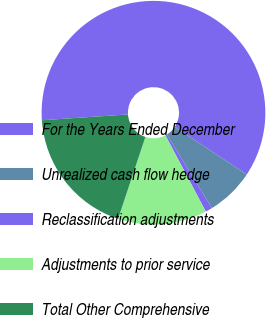Convert chart. <chart><loc_0><loc_0><loc_500><loc_500><pie_chart><fcel>For the Years Ended December<fcel>Unrealized cash flow hedge<fcel>Reclassification adjustments<fcel>Adjustments to prior service<fcel>Total Other Comprehensive<nl><fcel>60.38%<fcel>6.94%<fcel>1.0%<fcel>12.87%<fcel>18.81%<nl></chart> 